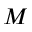Convert formula to latex. <formula><loc_0><loc_0><loc_500><loc_500>M</formula> 